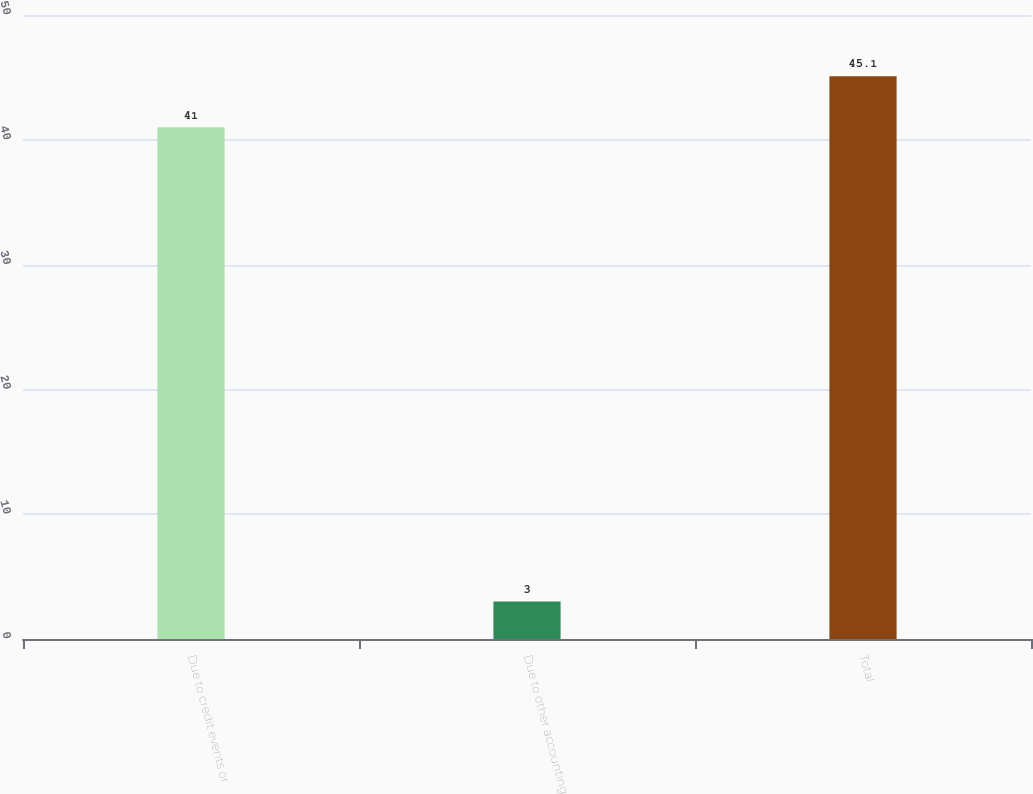Convert chart. <chart><loc_0><loc_0><loc_500><loc_500><bar_chart><fcel>Due to credit events or<fcel>Due to other accounting<fcel>Total<nl><fcel>41<fcel>3<fcel>45.1<nl></chart> 